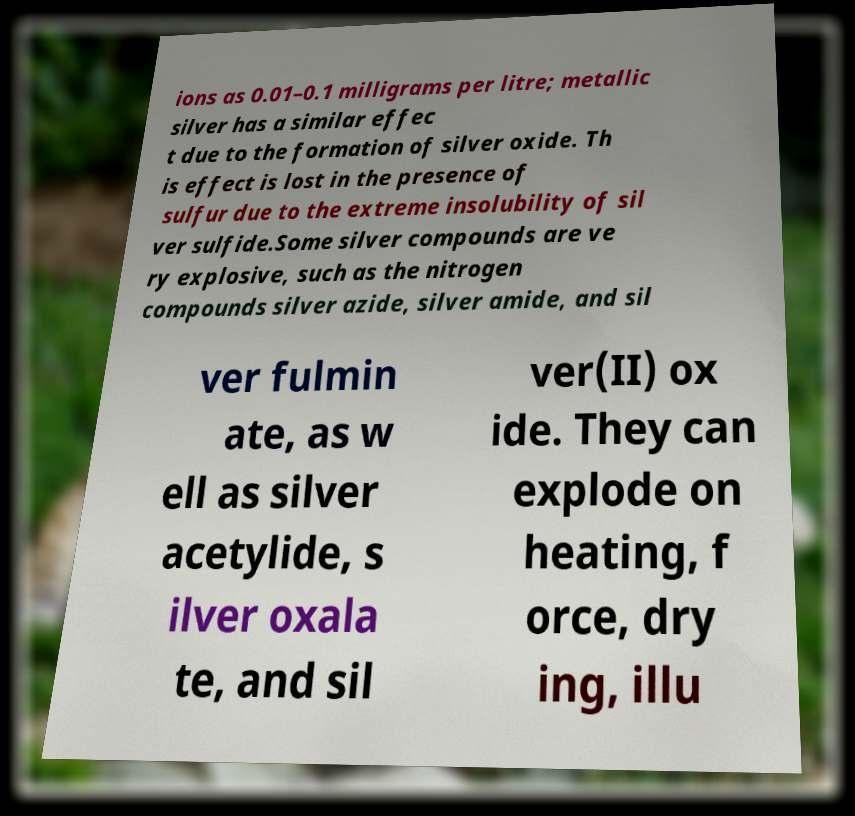Can you accurately transcribe the text from the provided image for me? ions as 0.01–0.1 milligrams per litre; metallic silver has a similar effec t due to the formation of silver oxide. Th is effect is lost in the presence of sulfur due to the extreme insolubility of sil ver sulfide.Some silver compounds are ve ry explosive, such as the nitrogen compounds silver azide, silver amide, and sil ver fulmin ate, as w ell as silver acetylide, s ilver oxala te, and sil ver(II) ox ide. They can explode on heating, f orce, dry ing, illu 